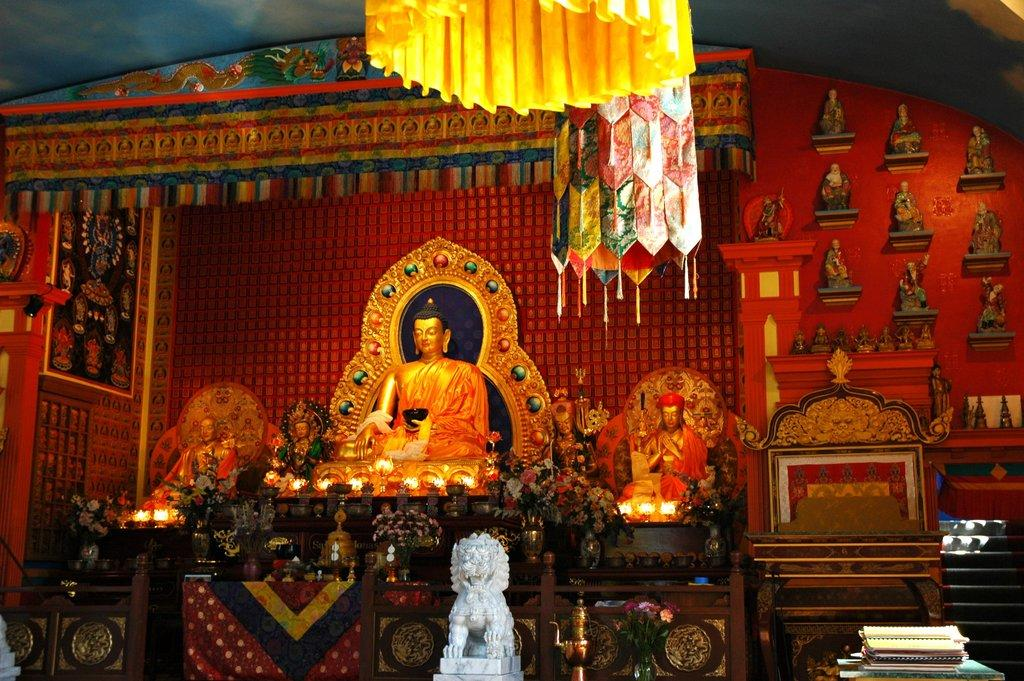What is the main subject of the image? There is a Buddha statue in the image. What color is the Buddha statue? The Buddha statue is orange. Are there any other statues in the image? Yes, there are other statues in the image. What can be seen in terms of lighting in the image? There are lights in the image. What color is the background of the image? The background of the image is red. What type of fabric is present in the image? There is a colorful cloth in the image. How many ants can be seen crawling on the Buddha statue in the image? There are no ants present on the Buddha statue in the image. What type of plants are growing around the statues in the image? There are no plants visible in the image. 